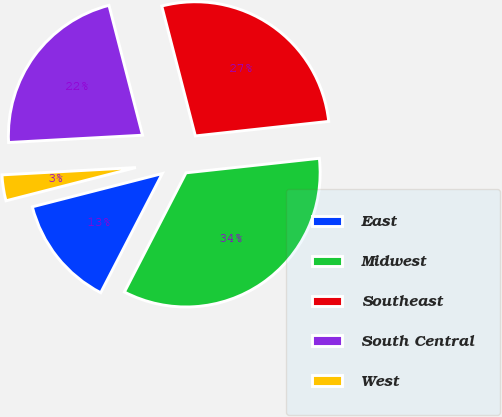Convert chart. <chart><loc_0><loc_0><loc_500><loc_500><pie_chart><fcel>East<fcel>Midwest<fcel>Southeast<fcel>South Central<fcel>West<nl><fcel>13.42%<fcel>34.32%<fcel>27.3%<fcel>21.84%<fcel>3.12%<nl></chart> 